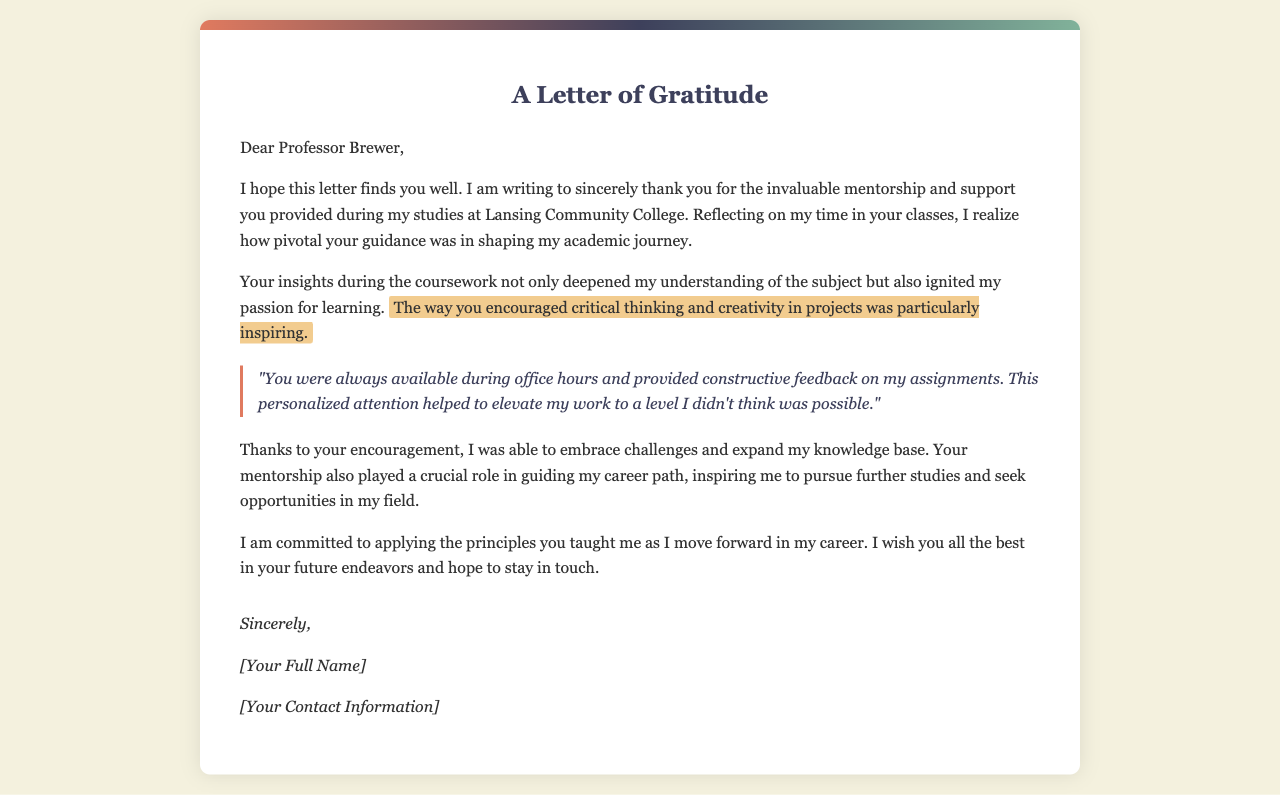What is the name of the professor addressed in the letter? The letter is addressed to Professor Brewer, indicating who the gratitude is directed towards.
Answer: Professor Brewer What institution did the sender attend? The sender mentions studying at Lansing Community College, which is the educational institution associated with the letter.
Answer: Lansing Community College What aspect of the professor's teaching is highlighted as inspiring? The letter notes that the professor encouraged critical thinking and creativity in projects, which had a significant impact on the sender's learning experience.
Answer: Critical thinking and creativity What type of support did the professor provide during the coursework? The letter indicates that the professor provided mentorship and personalized attention, particularly through office hours and constructive feedback.
Answer: Mentorship and personalized attention How did the sender feel about the feedback received on assignments? The feedback is described as constructive, which positively influenced the sender's work and academic performance.
Answer: Constructive feedback What future intention does the sender express in the letter? The sender expresses a commitment to applying the principles taught by the professor as they move forward in their career, indicating future aspirations.
Answer: Applying the principles taught What is the closing line of the letter? The closing line is a common way to end a letter, where the sender wishes the recipient well, suggesting a positive relationship.
Answer: I wish you all the best in your future endeavors What is included in the signature section? The signature section typically includes the sender's name and contact information, which identifies who wrote the letter and allows for future communication.
Answer: [Your Full Name] and [Your Contact Information] 